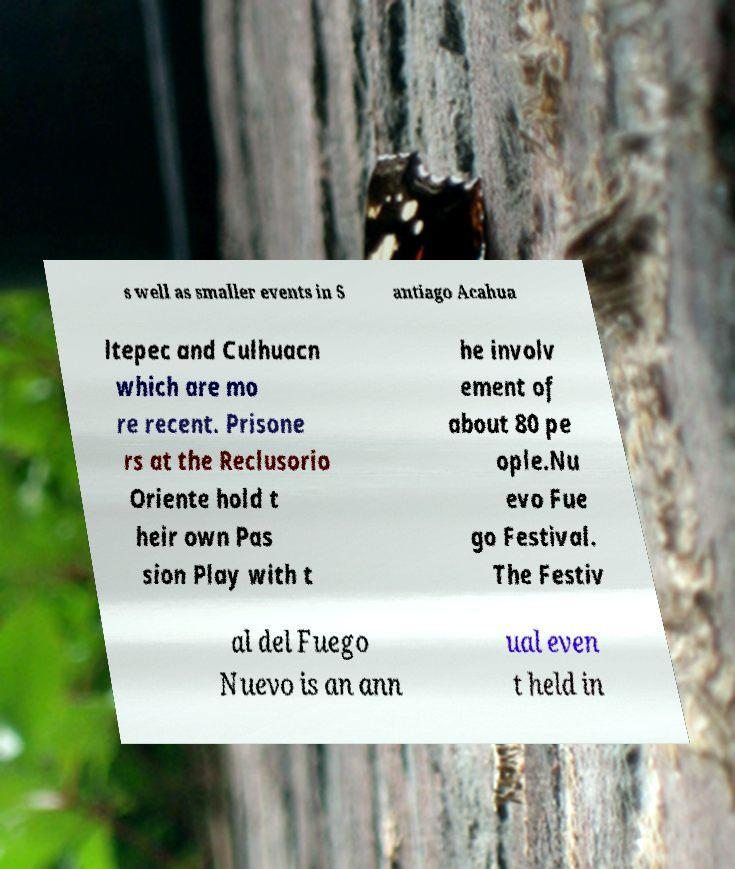Could you extract and type out the text from this image? s well as smaller events in S antiago Acahua ltepec and Culhuacn which are mo re recent. Prisone rs at the Reclusorio Oriente hold t heir own Pas sion Play with t he involv ement of about 80 pe ople.Nu evo Fue go Festival. The Festiv al del Fuego Nuevo is an ann ual even t held in 